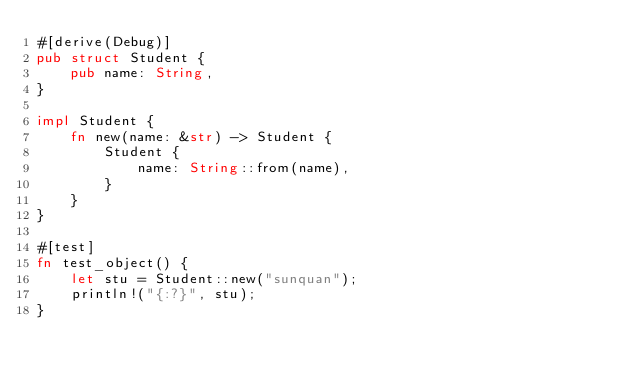Convert code to text. <code><loc_0><loc_0><loc_500><loc_500><_Rust_>#[derive(Debug)]
pub struct Student {
    pub name: String,
}

impl Student {
    fn new(name: &str) -> Student {
        Student {
            name: String::from(name),
        }
    }
}

#[test]
fn test_object() {
    let stu = Student::new("sunquan");
    println!("{:?}", stu);
}
</code> 